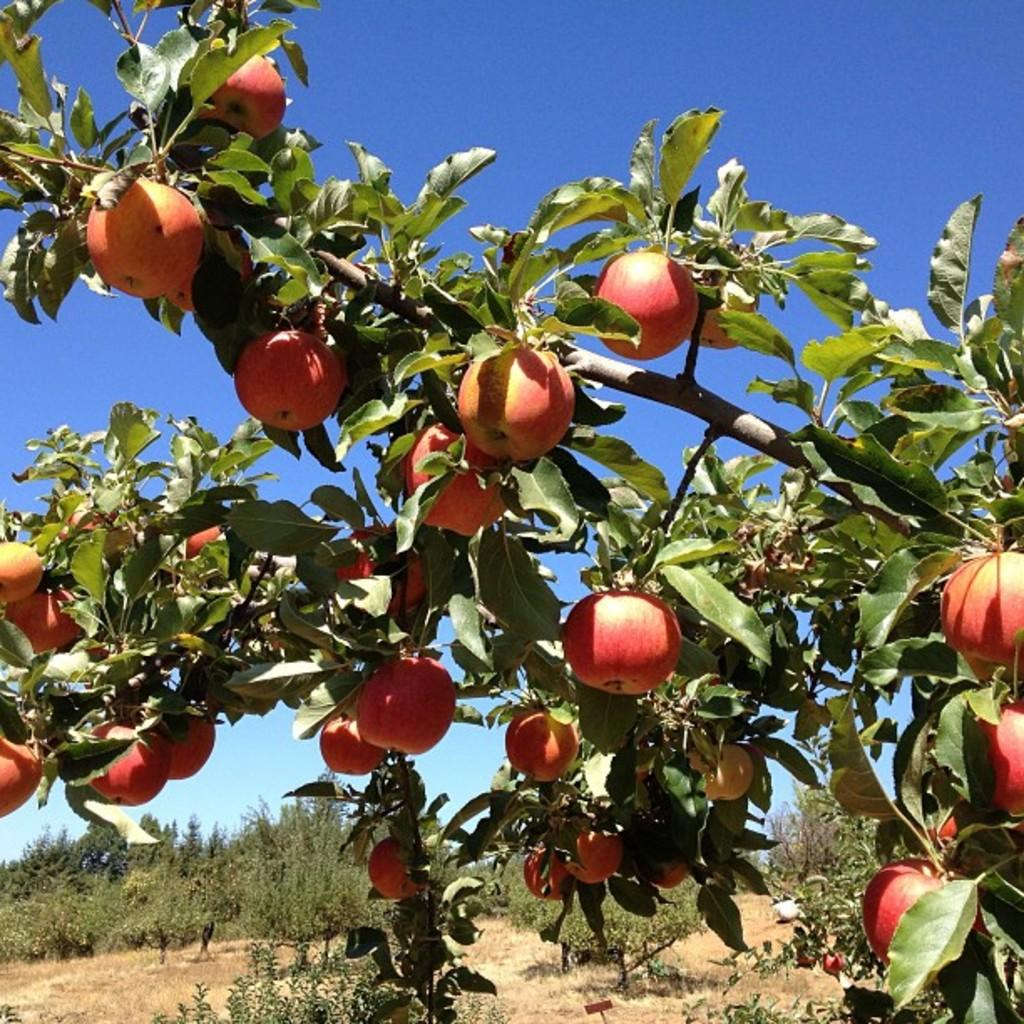What type of fruit can be seen on the tree in the image? There are apples on a tree in the image. What else can be seen in the background of the image besides the sky? There are trees in the background of the image. What is visible at the top of the image? The sky is visible in the background of the image. What type of brass instrument is being played in the image? There is no brass instrument present in the image; it features a tree with apples and a background with trees and sky. 